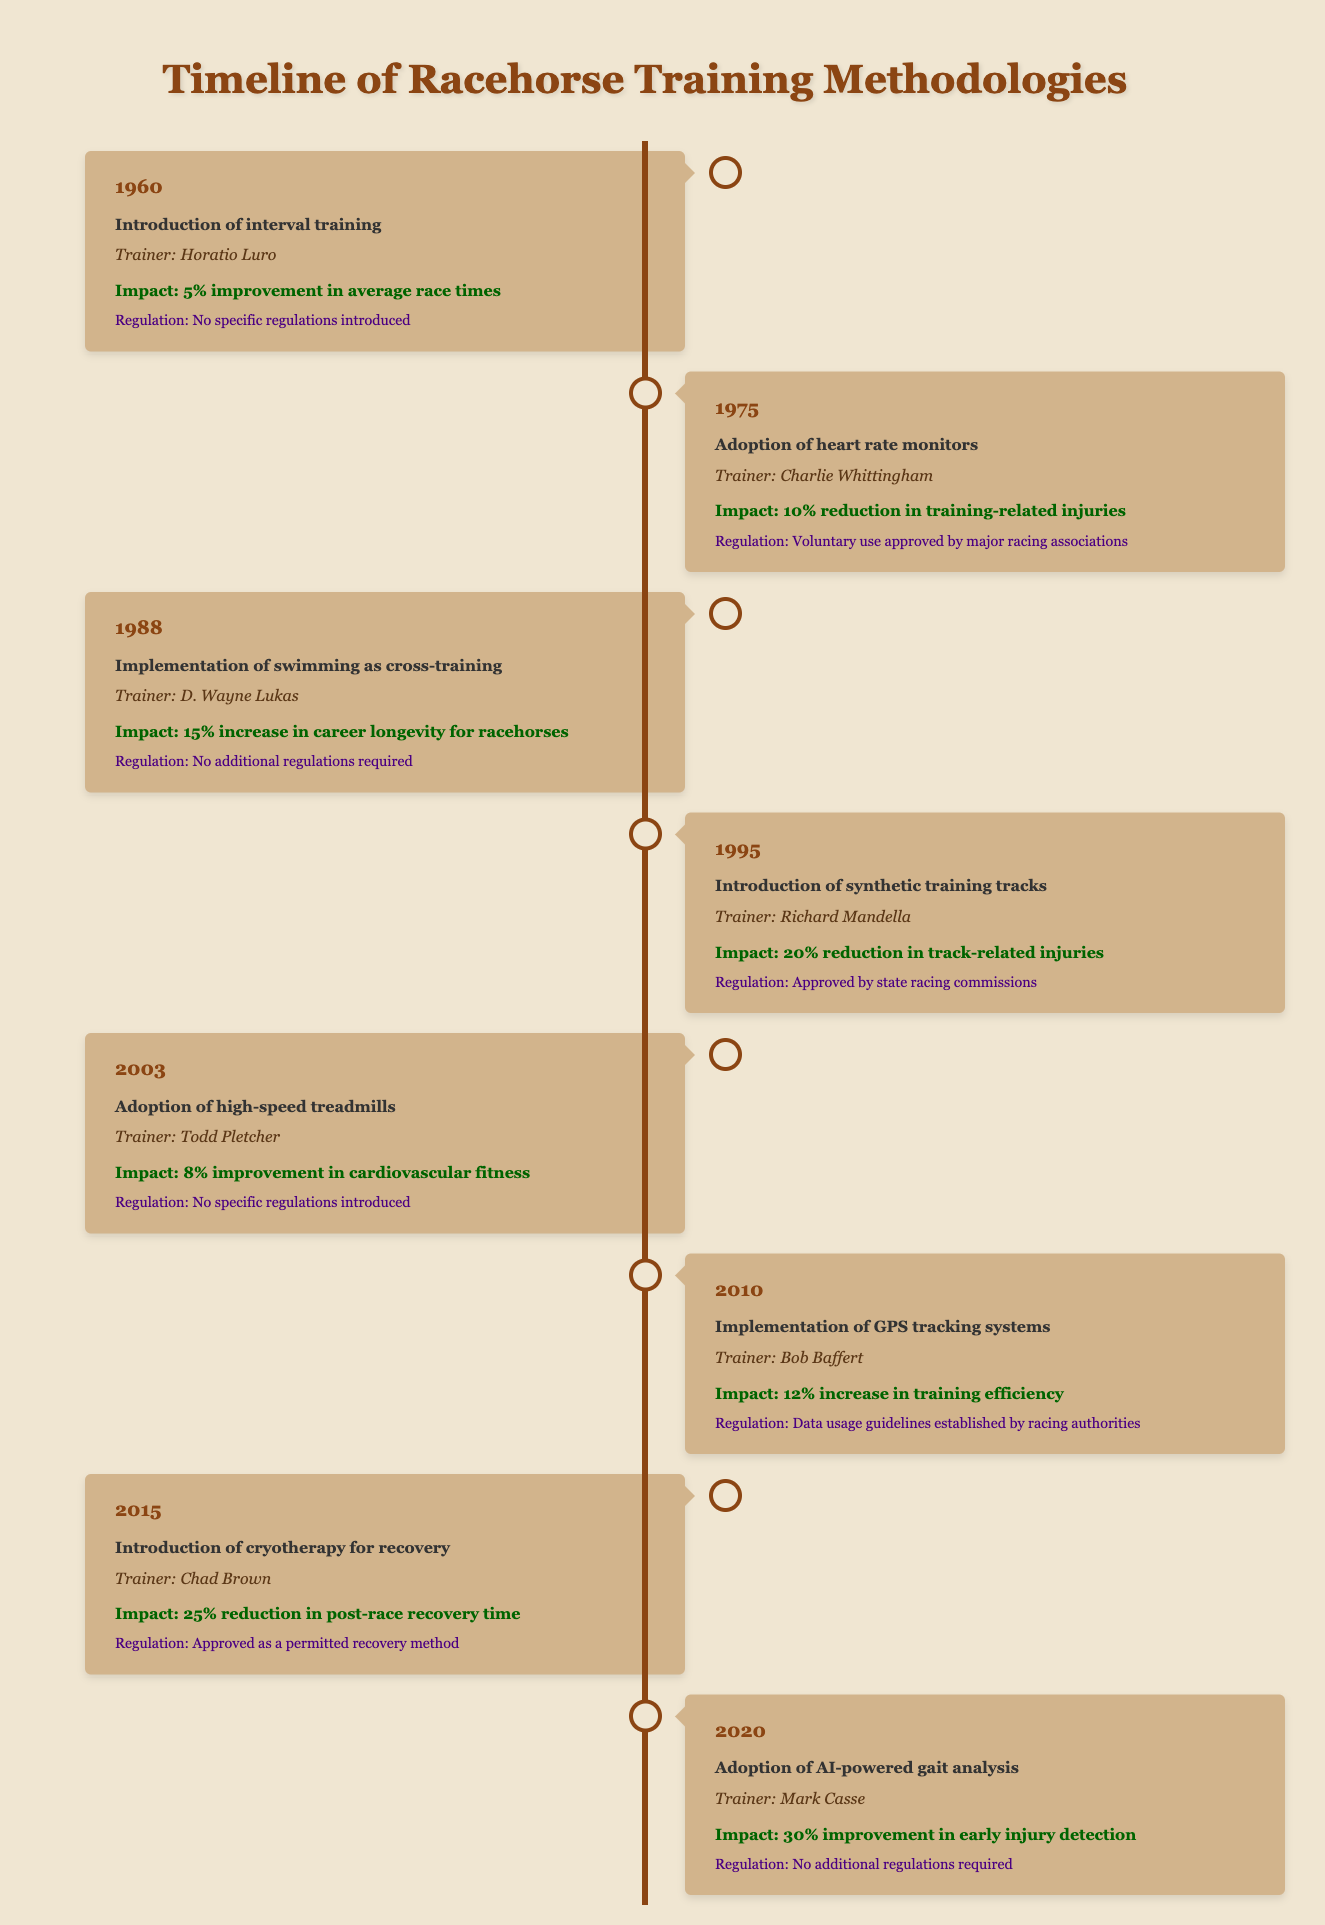What year was interval training introduced? The table's first entry states that interval training was introduced in the year 1960.
Answer: 1960 Which trainer implemented swimming as cross-training? According to the table, D. Wayne Lukas is listed as the trainer who implemented swimming as cross-training in 1988.
Answer: D. Wayne Lukas How much improvement in race times was noted with the introduction of interval training? The impact mentioned in the table related to interval training indicates a 5% improvement in average race times.
Answer: 5% What percentage reduction in training-related injuries was achieved with the adoption of heart rate monitors? The table specifies that the adoption of heart rate monitors led to a 10% reduction in training-related injuries according to Charlie Whittingham's entry.
Answer: 10% Is there a regulation associated with the introduction of AI-powered gait analysis? The table indicates that for AI-powered gait analysis in 2020, no additional regulations were required, making the statement true.
Answer: Yes Which training method had the highest reported impact on performance? Reviewing the impacts listed, cryotherapy for recovery shows the largest effect with a 25% reduction in post-race recovery time, the highest among all mentioned training methods.
Answer: Cryotherapy for recovery What was the average improvement percentage for race-related injuries from 1995 and 2015 events? The table shows a 20% reduction in track-related injuries from synthetic training tracks (1995) and a 25% reduction in post-race recovery time from cryotherapy (2015). The average is (20 + 25) / 2 = 22.5%.
Answer: 22.5% Which two training methodologies were introduced without any new regulations? Both the introduction of interval training in 1960 and the adoption of high-speed treadmills in 2003, as per the table, were introduced with no specific regulations.
Answer: Interval training and high-speed treadmills How did the implementation of GPS tracking systems affect training efficiency? The table indicates a 12% increase in training efficiency due to GPS tracking system implementations in 2010, attributed to trainer Bob Baffert.
Answer: 12% 